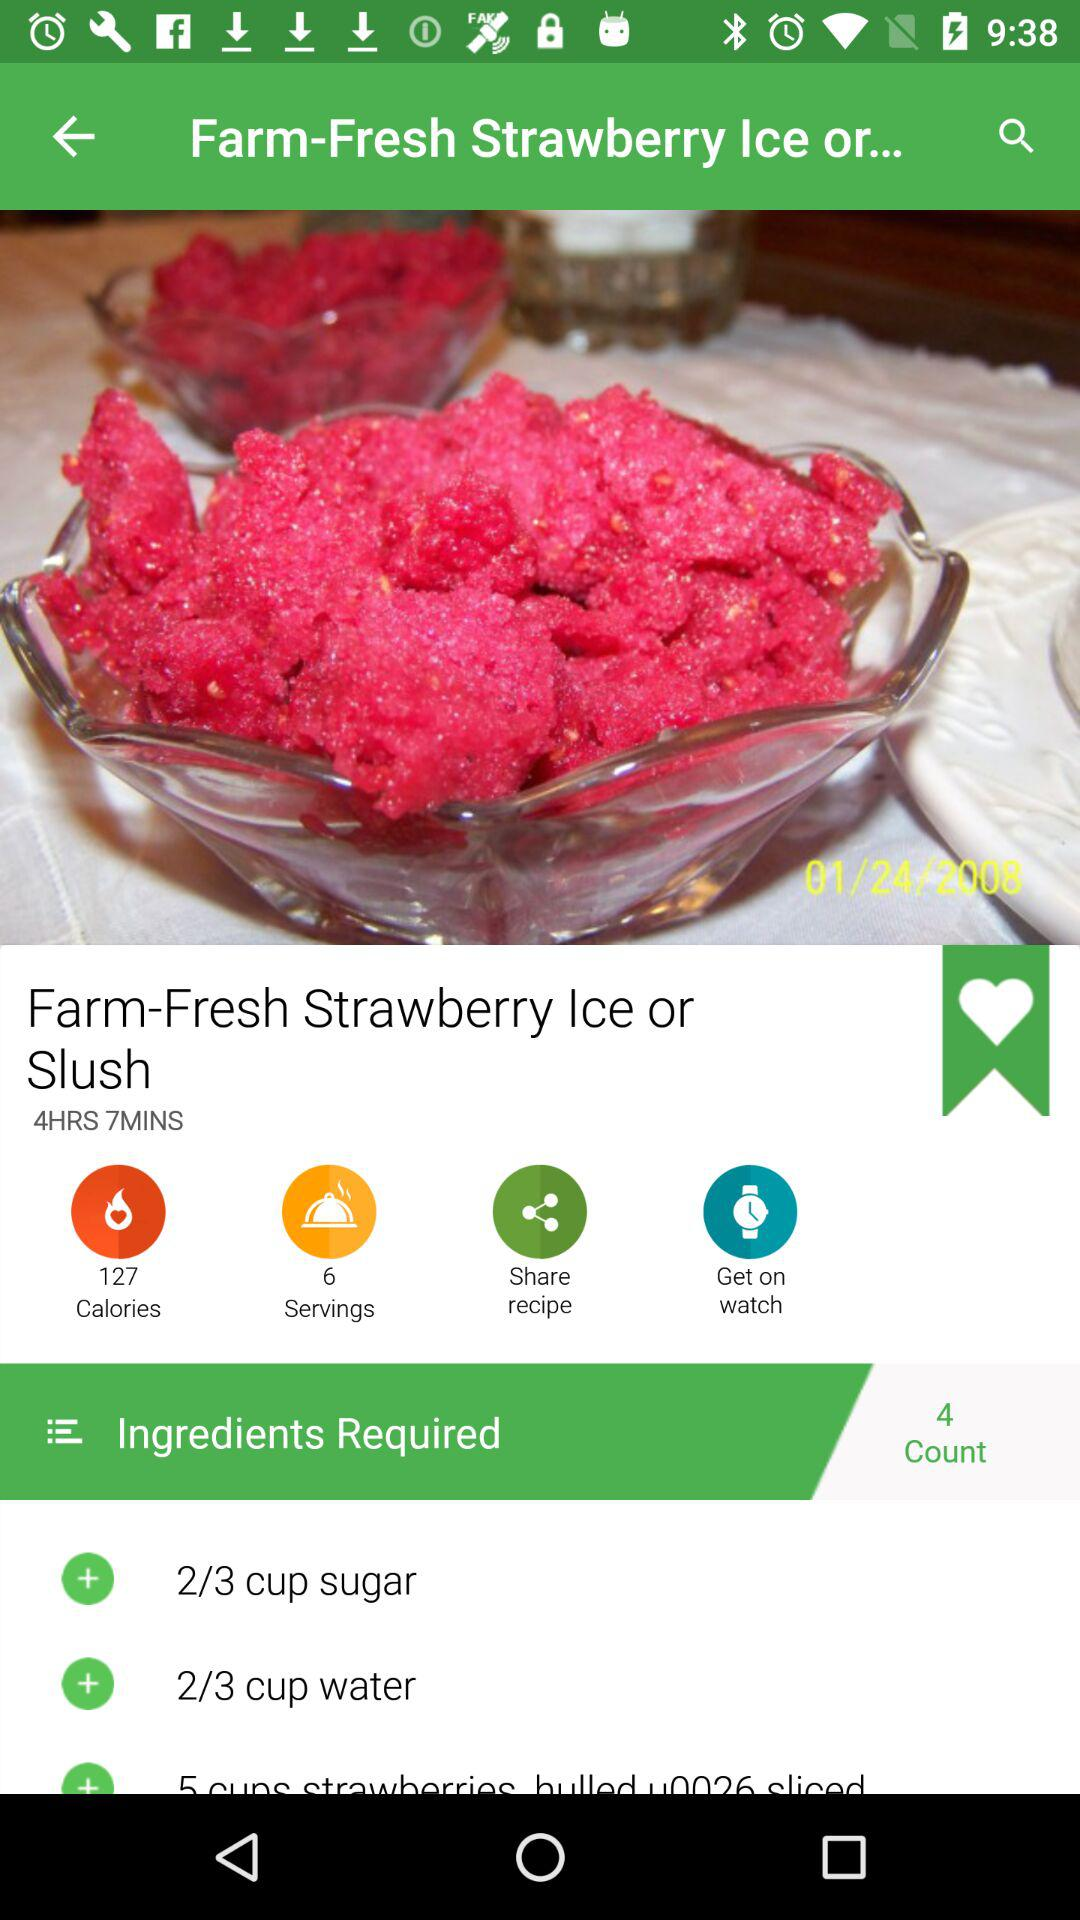What is the mentioned date? The mentioned date is January 24, 2008. 